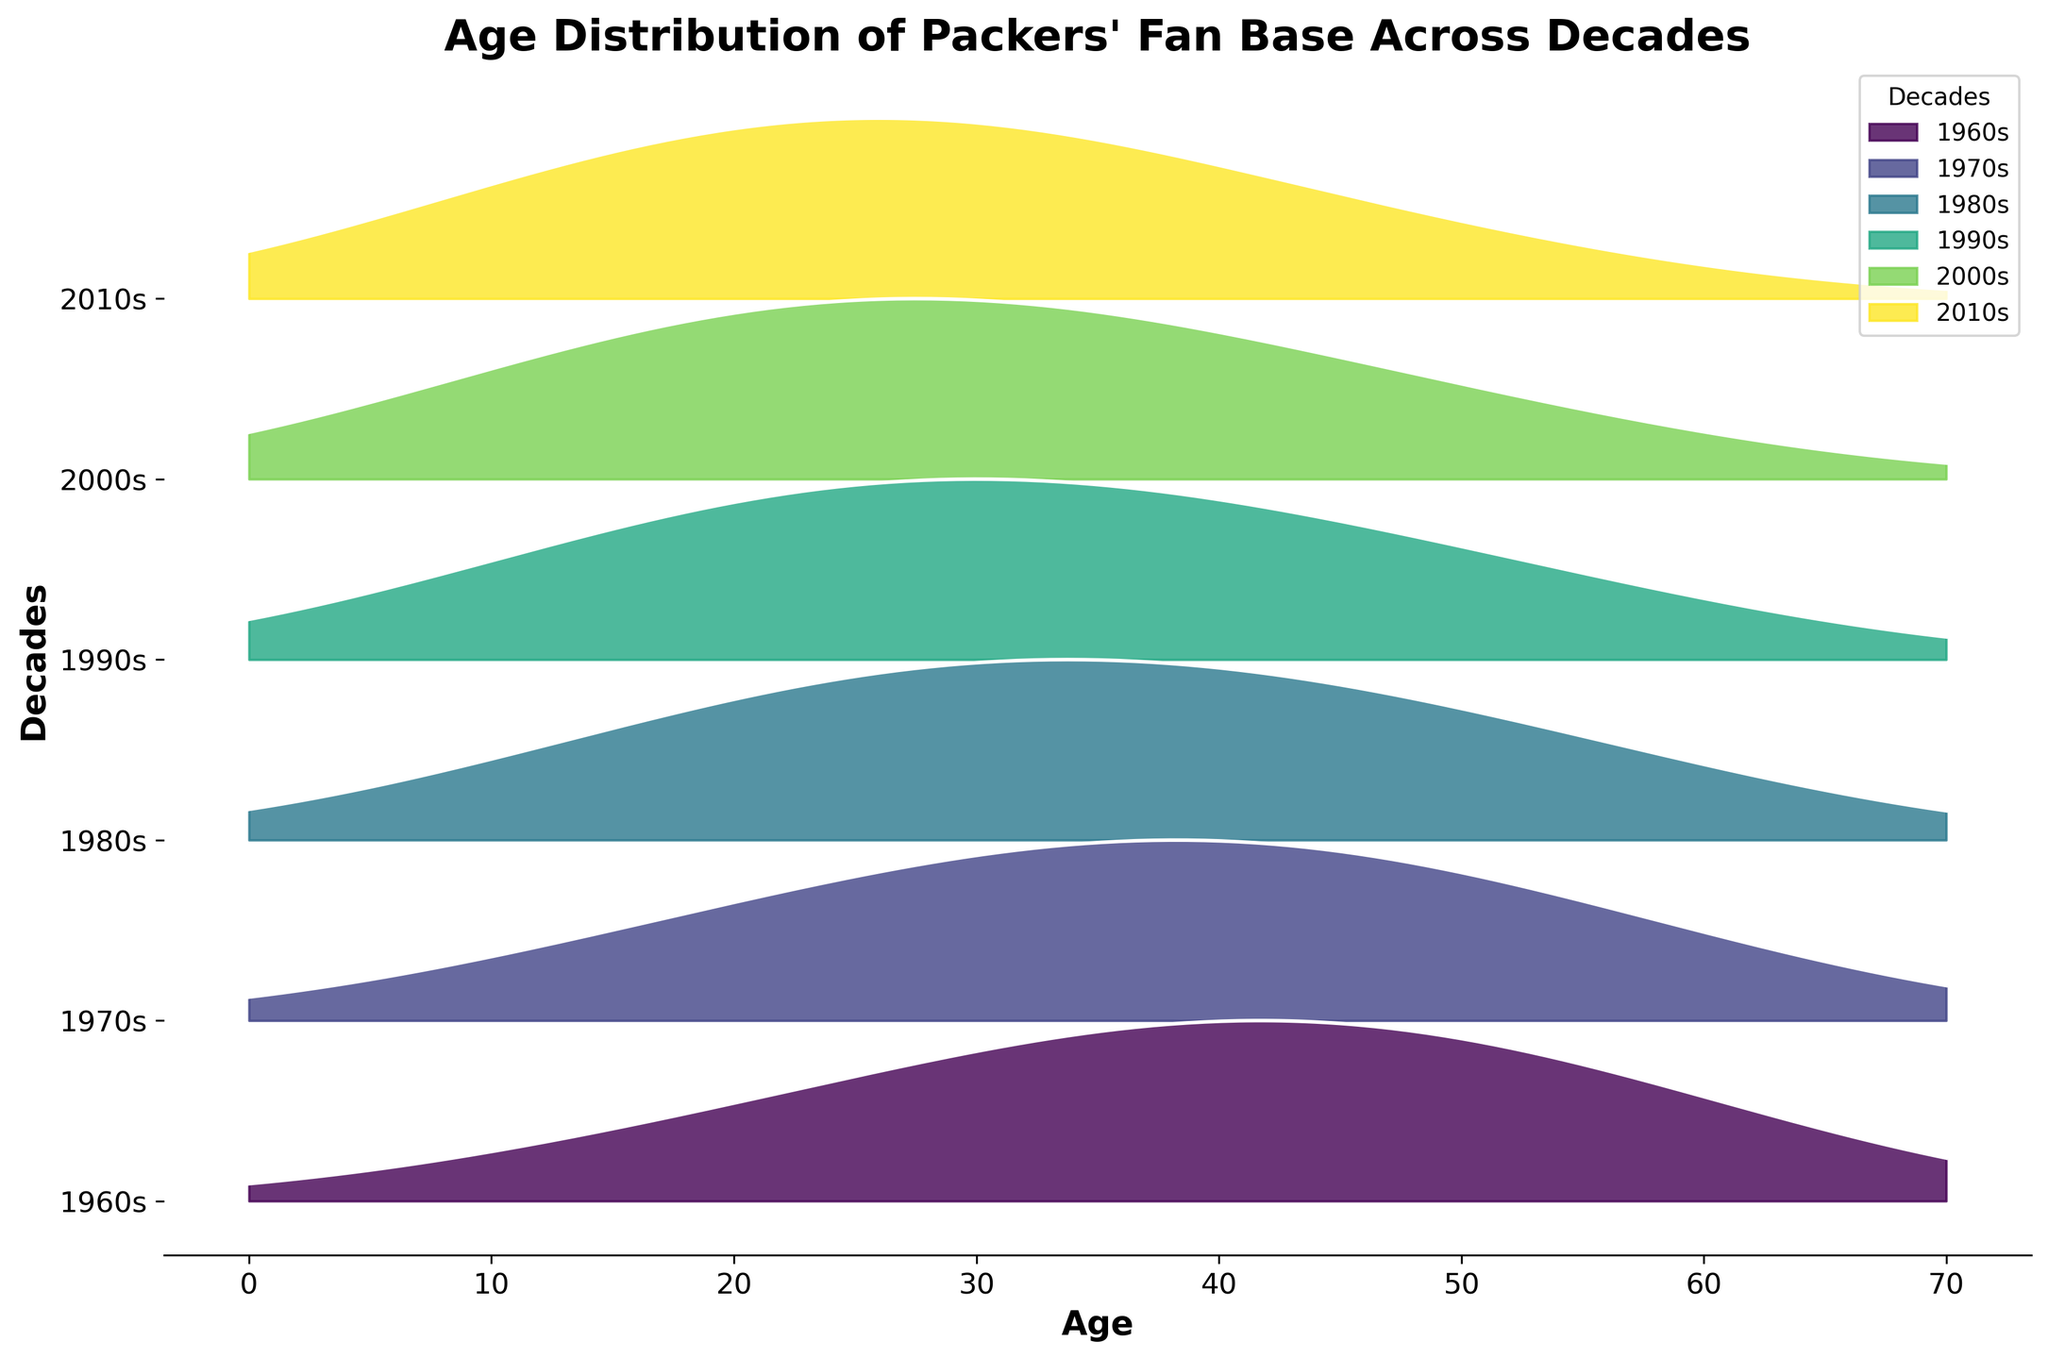What's the title of the plot? The title is displayed at the top of the plot. It reads "Age Distribution of Packers' Fan Base Across Decades".
Answer: Age Distribution of Packers' Fan Base Across Decades Which decade shows the highest density of fans in their 30s? By observing the peaks in the plot for each decade's distribution for the age around 30, the 2010s decade shows the highest density.
Answer: 2010s How does the fan density of the 1980s compare for ages 40 and 50? The height of the filled area in the plot for the 1980s at age 40 is taller than at age 50, indicating a higher density of fans in their 40s.
Answer: Higher for age 40 than age 50 For the 1970s, what is the trend in fan density from ages 10 to 50? From the plot, the density initially increases from age 10 to 40 and starts to decrease at age 50.
Answer: Increase then decrease Which decade has the most evenly distributed fan ages? The 2000s appear to have the most evenly distributed ages since the peaks are less pronounced and the density covers a broader age range.
Answer: 2000s At what age does the 1960s' fan density peak? The highest point of the curve for the 1960s is at age 40 as shown in the plot.
Answer: 40 In which decade is the lowest density observed for fans aged 60? At age 60, the 2010s show the lowest density, evidenced by the smallest filled area at that point in the plot.
Answer: 2010s How do the age distributions of fans in the 1990s and 2010s compare? The 1990s have a higher density in ages 10-40, while the 2010s have a slightly higher density in ages 10-30 and a sharper decline after age 30.
Answer: 1990s higher in 10-40, 2010s higher in 10-30 What is the general trend in the age distribution of fans from 1960s to 2010s? The fan base's peak age shifts younger over the decades, with each subsequent decade having its peak density at a younger age.
Answer: Shift towards younger ages 